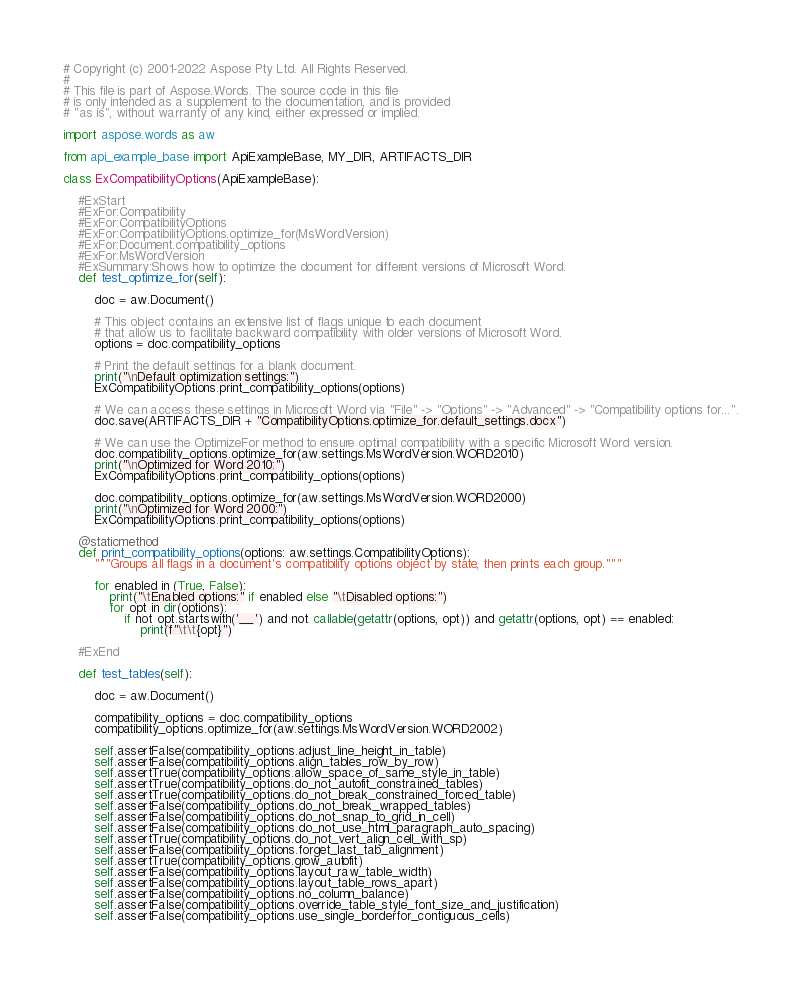<code> <loc_0><loc_0><loc_500><loc_500><_Python_># Copyright (c) 2001-2022 Aspose Pty Ltd. All Rights Reserved.
#
# This file is part of Aspose.Words. The source code in this file
# is only intended as a supplement to the documentation, and is provided
# "as is", without warranty of any kind, either expressed or implied.

import aspose.words as aw

from api_example_base import ApiExampleBase, MY_DIR, ARTIFACTS_DIR

class ExCompatibilityOptions(ApiExampleBase):

    #ExStart
    #ExFor:Compatibility
    #ExFor:CompatibilityOptions
    #ExFor:CompatibilityOptions.optimize_for(MsWordVersion)
    #ExFor:Document.compatibility_options
    #ExFor:MsWordVersion
    #ExSummary:Shows how to optimize the document for different versions of Microsoft Word.
    def test_optimize_for(self):

        doc = aw.Document()

        # This object contains an extensive list of flags unique to each document
        # that allow us to facilitate backward compatibility with older versions of Microsoft Word.
        options = doc.compatibility_options

        # Print the default settings for a blank document.
        print("\nDefault optimization settings:")
        ExCompatibilityOptions.print_compatibility_options(options)

        # We can access these settings in Microsoft Word via "File" -> "Options" -> "Advanced" -> "Compatibility options for...".
        doc.save(ARTIFACTS_DIR + "CompatibilityOptions.optimize_for.default_settings.docx")

        # We can use the OptimizeFor method to ensure optimal compatibility with a specific Microsoft Word version.
        doc.compatibility_options.optimize_for(aw.settings.MsWordVersion.WORD2010)
        print("\nOptimized for Word 2010:")
        ExCompatibilityOptions.print_compatibility_options(options)

        doc.compatibility_options.optimize_for(aw.settings.MsWordVersion.WORD2000)
        print("\nOptimized for Word 2000:")
        ExCompatibilityOptions.print_compatibility_options(options)

    @staticmethod
    def print_compatibility_options(options: aw.settings.CompatibilityOptions):
        """Groups all flags in a document's compatibility options object by state, then prints each group."""

        for enabled in (True, False):
            print("\tEnabled options:" if enabled else "\tDisabled options:")
            for opt in dir(options):
                if not opt.startswith('__') and not callable(getattr(options, opt)) and getattr(options, opt) == enabled:
                    print(f"\t\t{opt}")

    #ExEnd

    def test_tables(self):

        doc = aw.Document()

        compatibility_options = doc.compatibility_options
        compatibility_options.optimize_for(aw.settings.MsWordVersion.WORD2002)

        self.assertFalse(compatibility_options.adjust_line_height_in_table)
        self.assertFalse(compatibility_options.align_tables_row_by_row)
        self.assertTrue(compatibility_options.allow_space_of_same_style_in_table)
        self.assertTrue(compatibility_options.do_not_autofit_constrained_tables)
        self.assertTrue(compatibility_options.do_not_break_constrained_forced_table)
        self.assertFalse(compatibility_options.do_not_break_wrapped_tables)
        self.assertFalse(compatibility_options.do_not_snap_to_grid_in_cell)
        self.assertFalse(compatibility_options.do_not_use_html_paragraph_auto_spacing)
        self.assertTrue(compatibility_options.do_not_vert_align_cell_with_sp)
        self.assertFalse(compatibility_options.forget_last_tab_alignment)
        self.assertTrue(compatibility_options.grow_autofit)
        self.assertFalse(compatibility_options.layout_raw_table_width)
        self.assertFalse(compatibility_options.layout_table_rows_apart)
        self.assertFalse(compatibility_options.no_column_balance)
        self.assertFalse(compatibility_options.override_table_style_font_size_and_justification)
        self.assertFalse(compatibility_options.use_single_borderfor_contiguous_cells)</code> 